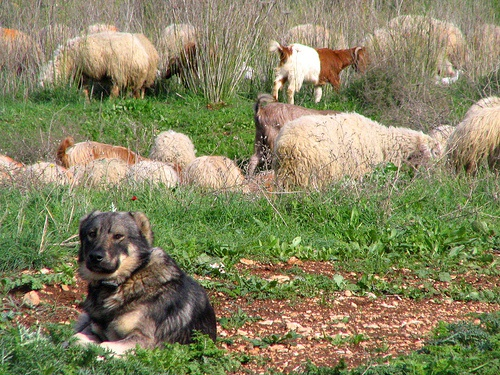Describe the objects in this image and their specific colors. I can see dog in gray, black, and darkgray tones, sheep in gray, ivory, and tan tones, sheep in gray, tan, and ivory tones, sheep in gray, ivory, brown, and olive tones, and sheep in gray, tan, and darkgray tones in this image. 